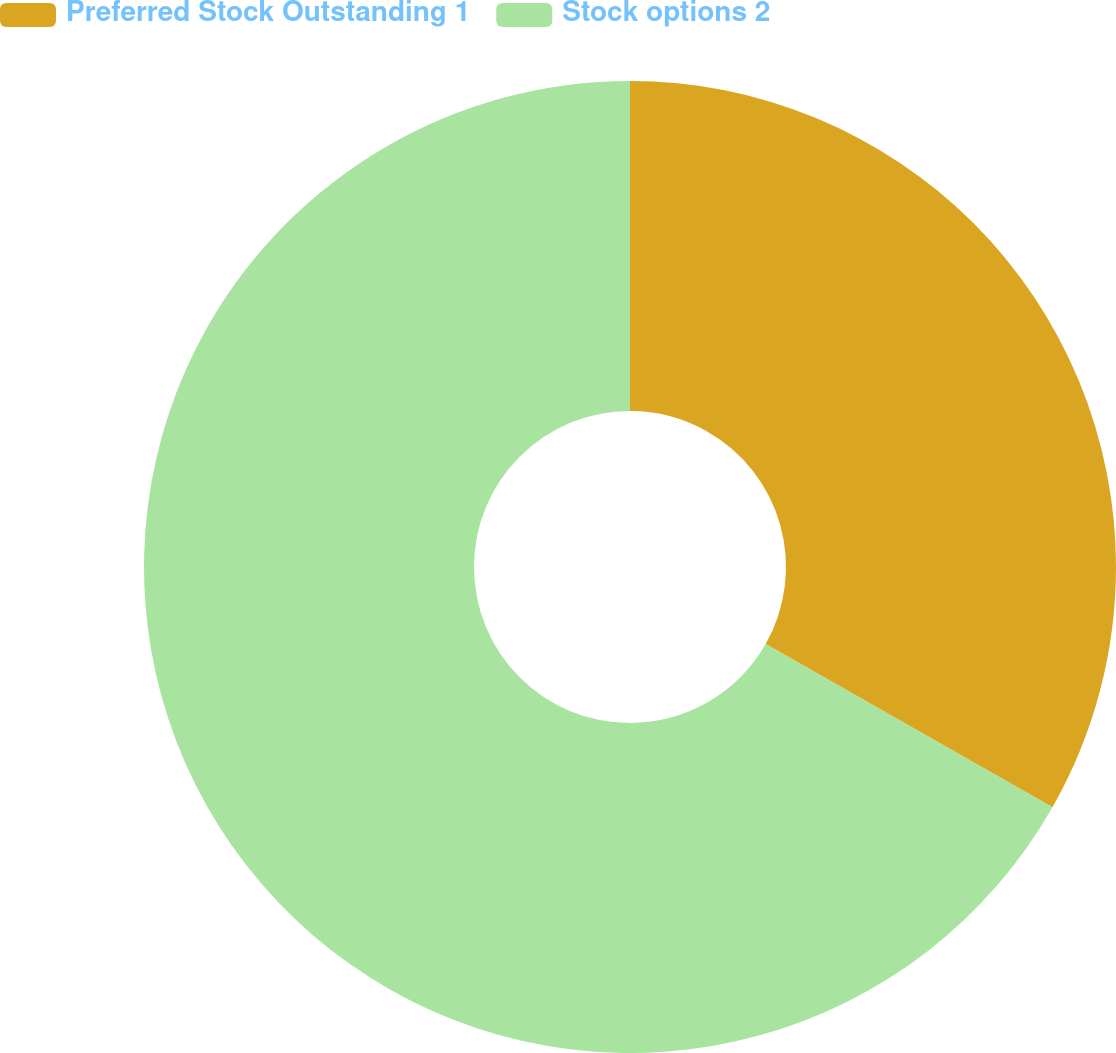<chart> <loc_0><loc_0><loc_500><loc_500><pie_chart><fcel>Preferred Stock Outstanding 1<fcel>Stock options 2<nl><fcel>33.23%<fcel>66.77%<nl></chart> 